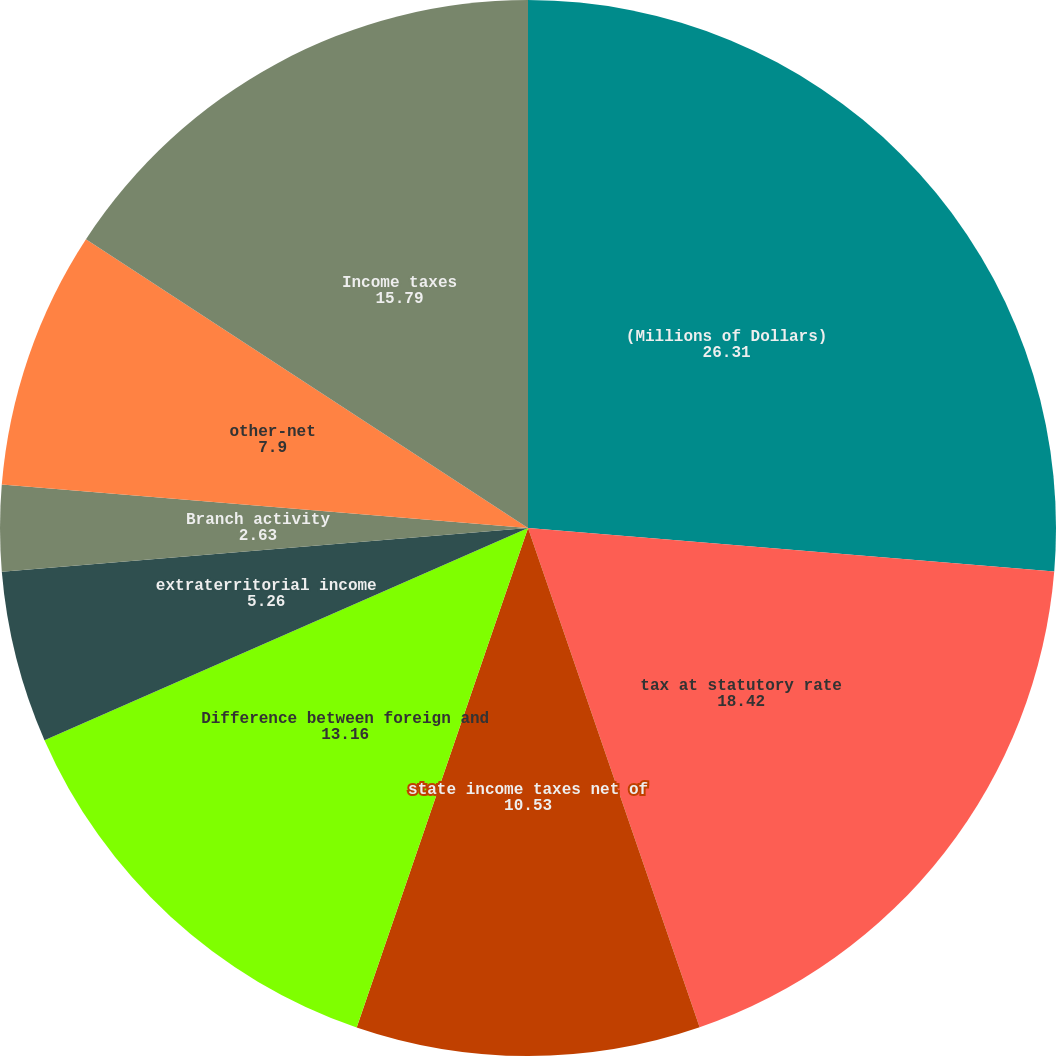Convert chart to OTSL. <chart><loc_0><loc_0><loc_500><loc_500><pie_chart><fcel>(Millions of Dollars)<fcel>tax at statutory rate<fcel>state income taxes net of<fcel>Difference between foreign and<fcel>extraterritorial income<fcel>Branch activity<fcel>tax accrual reserve<fcel>other-net<fcel>Income taxes<nl><fcel>26.31%<fcel>18.42%<fcel>10.53%<fcel>13.16%<fcel>5.26%<fcel>2.63%<fcel>0.0%<fcel>7.9%<fcel>15.79%<nl></chart> 